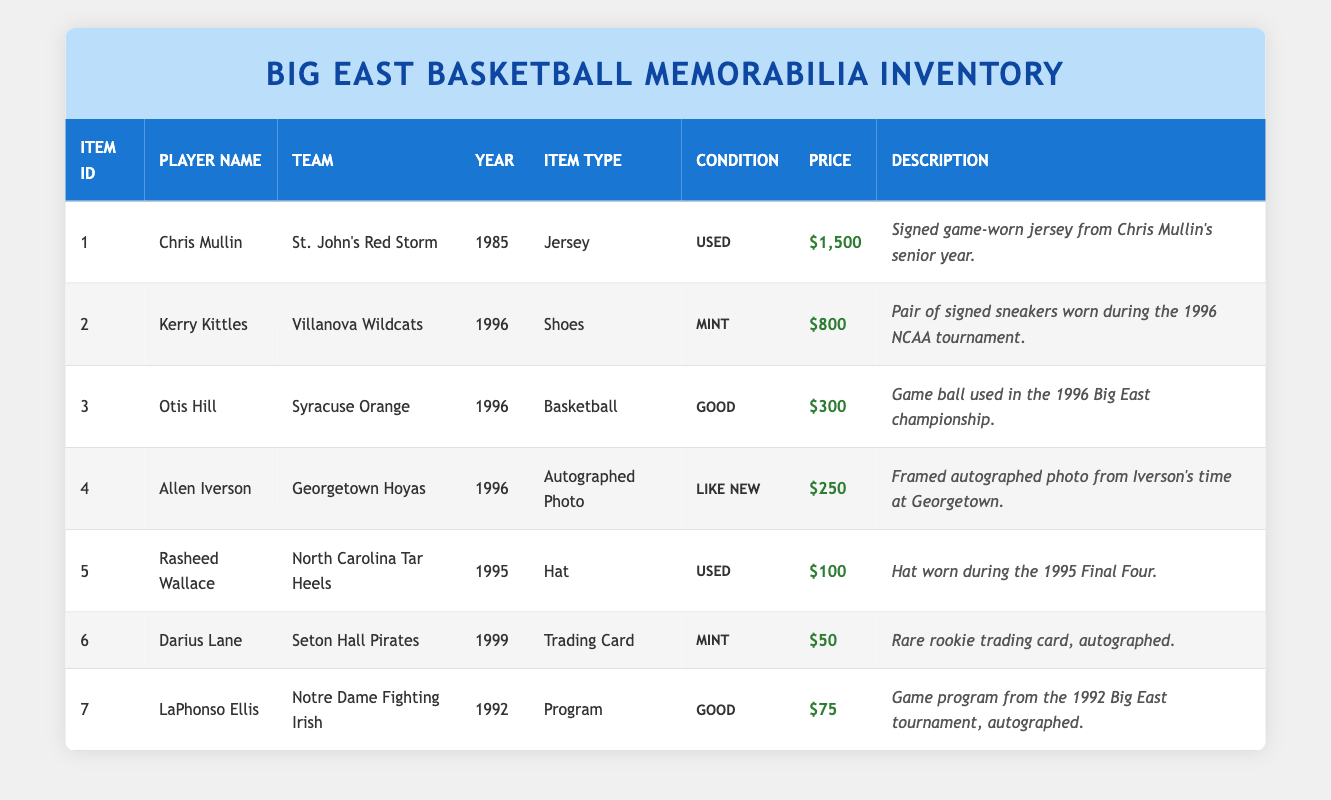What is the price of Chris Mullin's signed jersey? The table lists the item under Chris Mullin, which shows that his signed game-worn jersey from 1985 is priced at $1,500.
Answer: $1,500 Which player has the item with the highest price? By examining the price column, Chris Mullin's jersey at $1,500 is the highest compared to other items.
Answer: Chris Mullin What condition is Allen Iverson's autographed photo in? The condition column for Allen Iverson's item indicates it is in "Like New" condition.
Answer: Like New What is the total price of all memorabilia items from the year 1996? First, we identify the items from 1996: Kerry Kittles's shoes ($800), Otis Hill's basketball ($300), and Allen Iverson's photo ($250). Then we add them: 800 + 300 + 250 = $1,350.
Answer: $1,350 Is there an item listed from the year 1992? Looking through the year column, we find LaPhonso Ellis's program from 1992, confirming the existence of an item from that year.
Answer: Yes How many items are listed in good condition? We check the condition column and find Otis Hill's basketball, LaPhonso Ellis's program, and another item that is in "Good" condition. Thus, there are 3 items in good condition.
Answer: 3 Which team’s memorabilia has the lowest price? The lowest price item is Darius Lane's trading card priced at $50, associated with the Seton Hall Pirates. This is the only price below $75 among the listed items.
Answer: Seton Hall Pirates What is the average price of items in mint condition? There are two items in mint condition: Kerry Kittles's shoes ($800) and Darius Lane's trading card ($50). To find the average, we total the prices: 800 + 50 = $850, then divide by 2, which gives us $425.
Answer: $425 Identify any items related to the Final Four. The table notes Rasheed Wallace's hat worn during the 1995 Final Four. This is the only item specifically mentioned related to that event.
Answer: Yes 